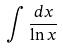Convert formula to latex. <formula><loc_0><loc_0><loc_500><loc_500>\int \frac { d x } { \ln x }</formula> 